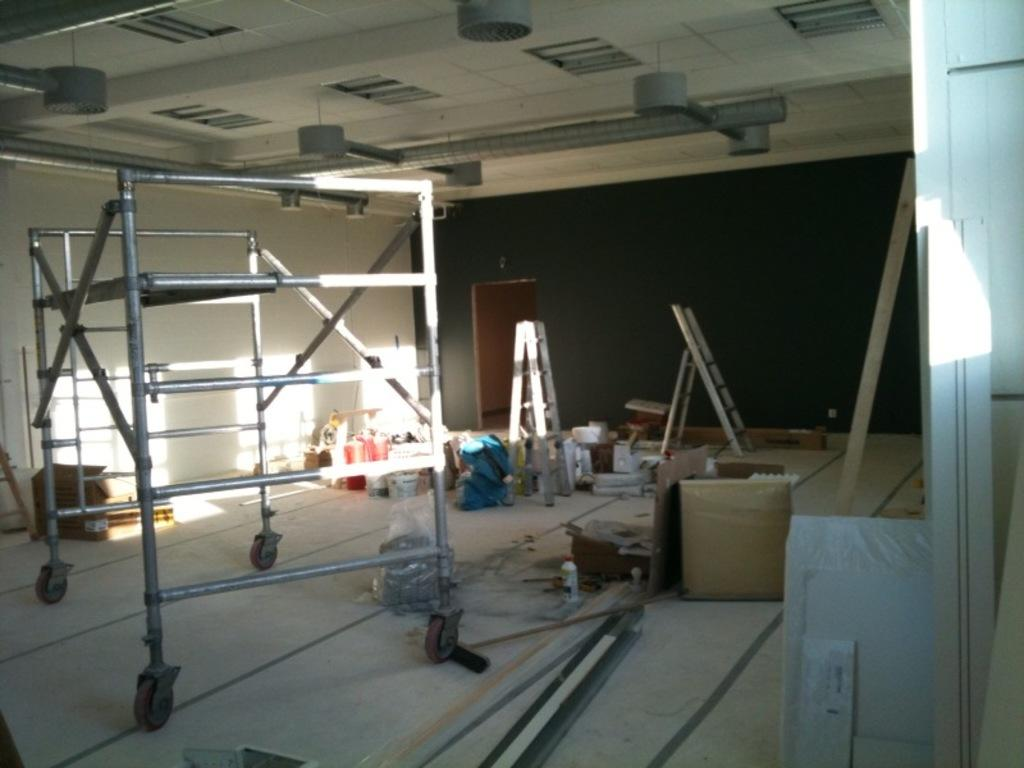What type of material is used for the rods in the image? The rods in the image are made of metal. What can be seen in the image besides the metal rods? There are carton boxes and various other items on the floor in the image. Can you describe the leaders in the image? The leaders in the image are possibly referring to people or objects, but their specific characteristics are not mentioned in the provided facts. How does the fog affect the visibility of the items in the image? There is no fog present in the image, so its effect on the visibility of the items cannot be determined. 